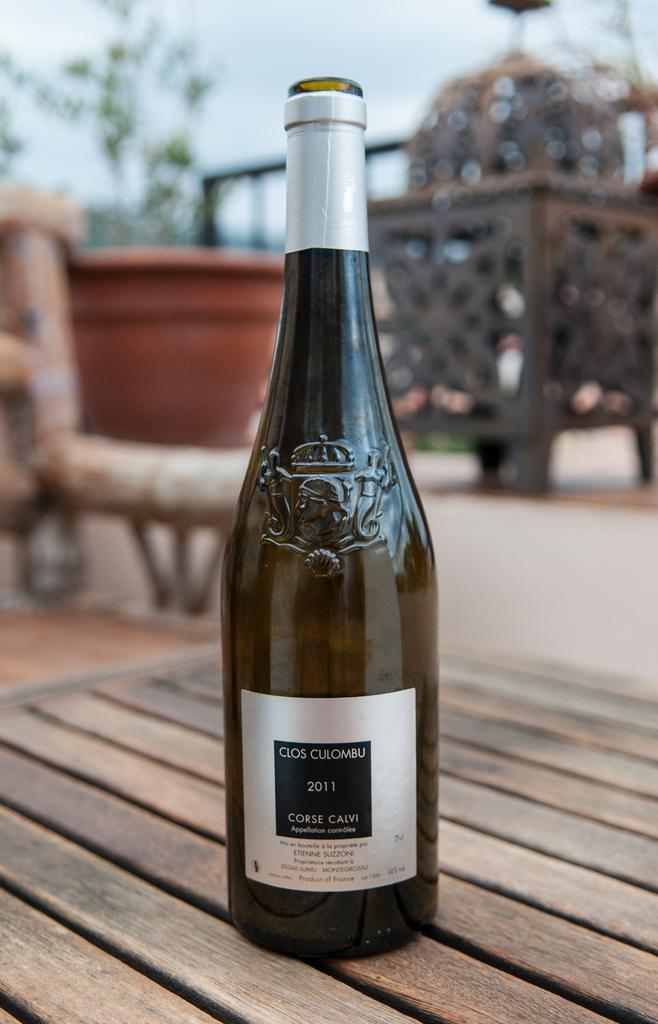<image>
Render a clear and concise summary of the photo. A bottle of Clos Culombu wine sits on a wooden table. 